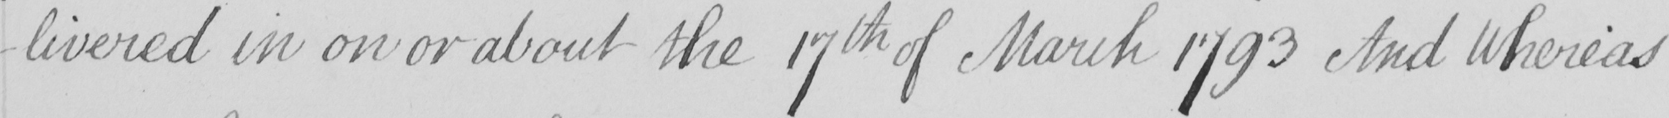Can you read and transcribe this handwriting? -livered in on or about the 17th of March 1793 And Whereas 